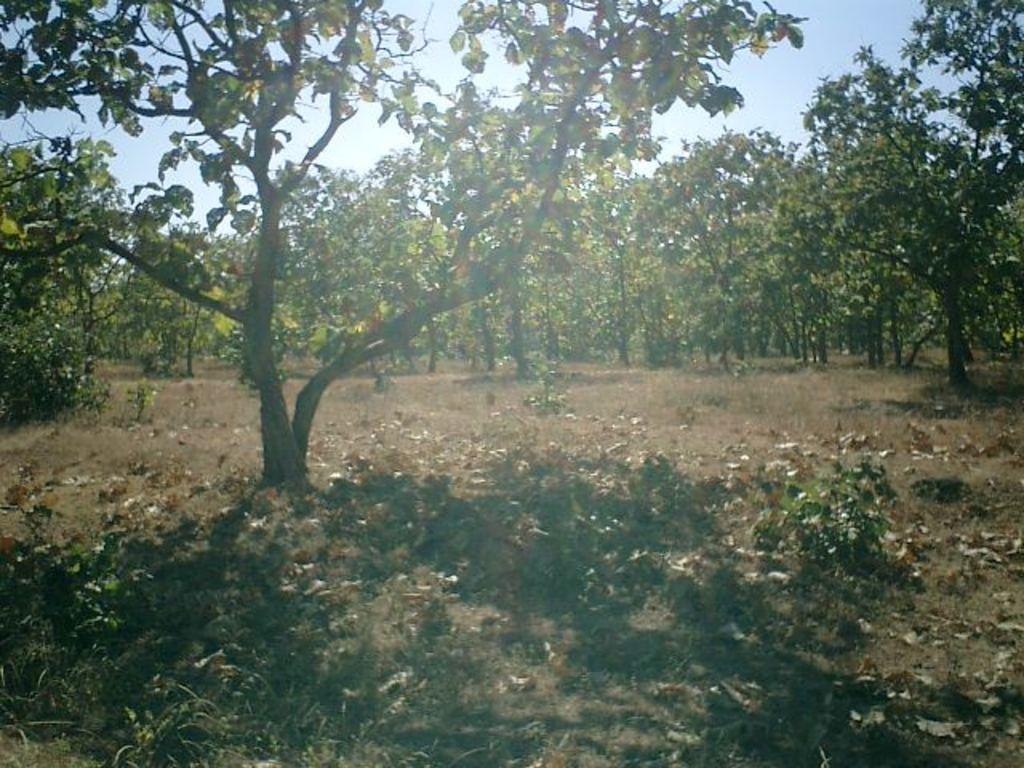In one or two sentences, can you explain what this image depicts? In this picture I can see number of trees and in the background I see the sky. 